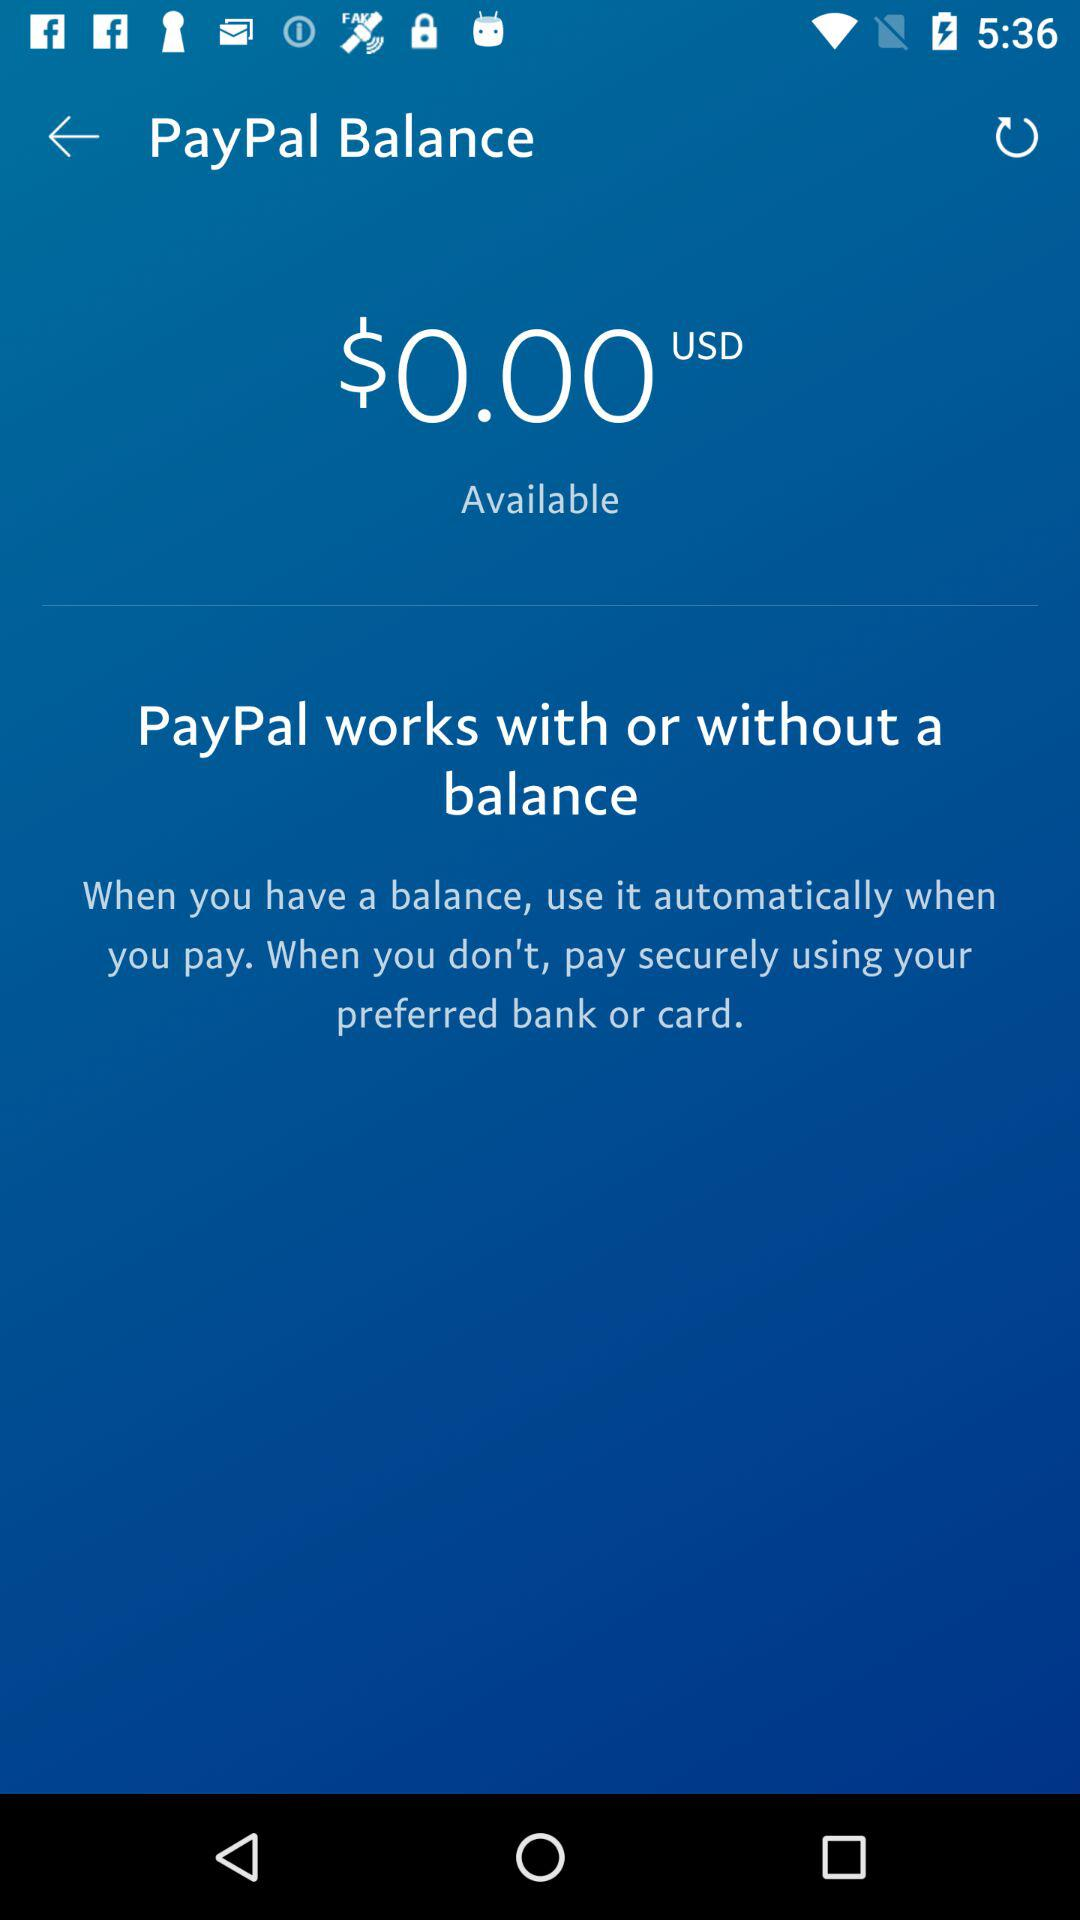What currency is my PayPal balance in?
Answer the question using a single word or phrase. USD 